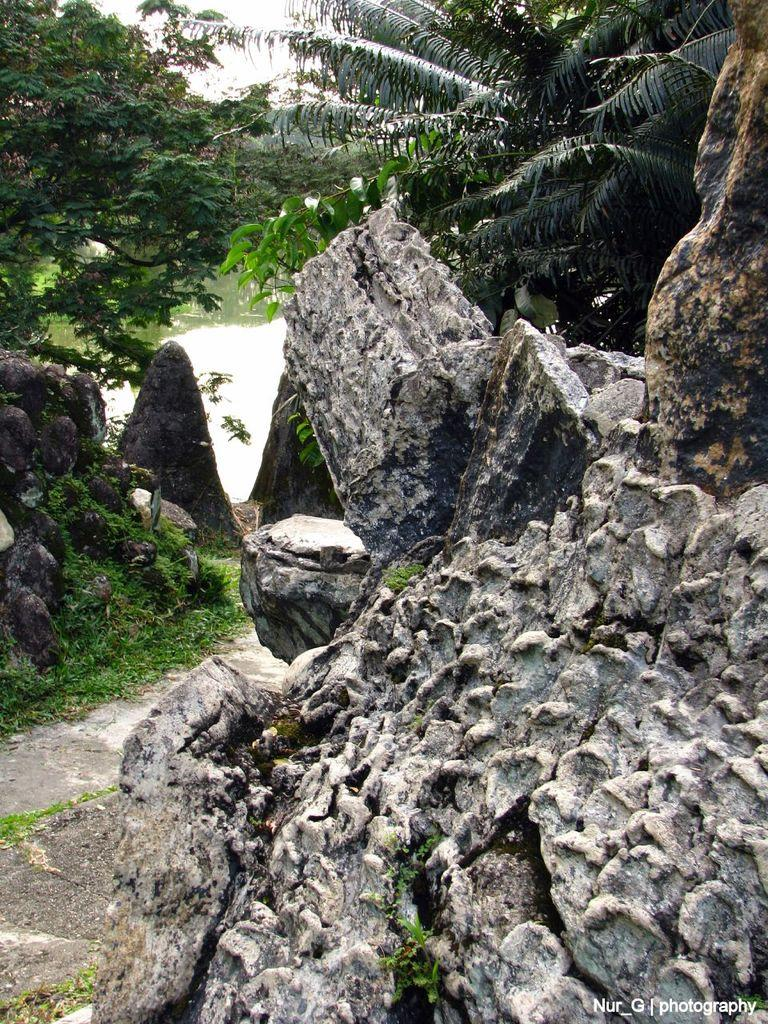What type of natural elements can be seen in the image? There are rocks, trees, and grass visible in the image. What can be seen in the background of the image? There is water and the sky visible in the background of the image. How many types of vegetation are present in the image? There are two types of vegetation present: trees and grass. What type of brick structure can be seen in the image? There is no brick structure present in the image; it features natural elements such as rocks, trees, and grass. What is the interest rate for the loan mentioned in the image? There is no mention of a loan or interest rate in the image. 